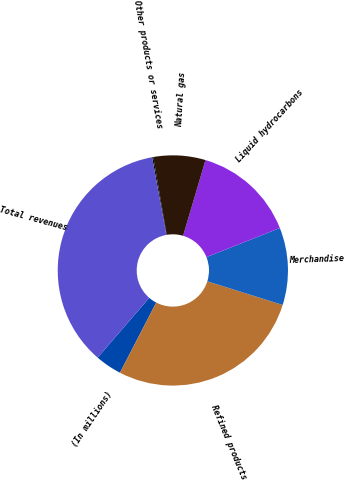Convert chart to OTSL. <chart><loc_0><loc_0><loc_500><loc_500><pie_chart><fcel>(In millions)<fcel>Refined products<fcel>Merchandise<fcel>Liquid hydrocarbons<fcel>Natural gas<fcel>Other products or services<fcel>Total revenues<nl><fcel>3.73%<fcel>27.75%<fcel>10.85%<fcel>14.41%<fcel>7.29%<fcel>0.17%<fcel>35.78%<nl></chart> 